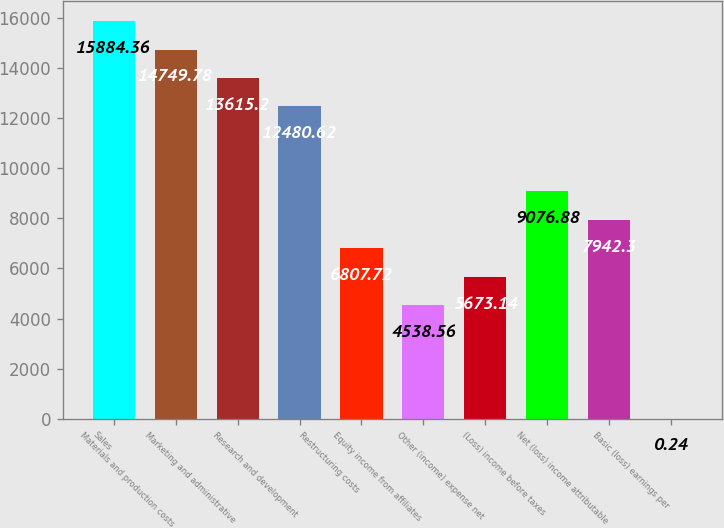Convert chart. <chart><loc_0><loc_0><loc_500><loc_500><bar_chart><fcel>Sales<fcel>Materials and production costs<fcel>Marketing and administrative<fcel>Research and development<fcel>Restructuring costs<fcel>Equity income from affiliates<fcel>Other (income) expense net<fcel>(Loss) income before taxes<fcel>Net (loss) income attributable<fcel>Basic (loss) earnings per<nl><fcel>15884.4<fcel>14749.8<fcel>13615.2<fcel>12480.6<fcel>6807.72<fcel>4538.56<fcel>5673.14<fcel>9076.88<fcel>7942.3<fcel>0.24<nl></chart> 